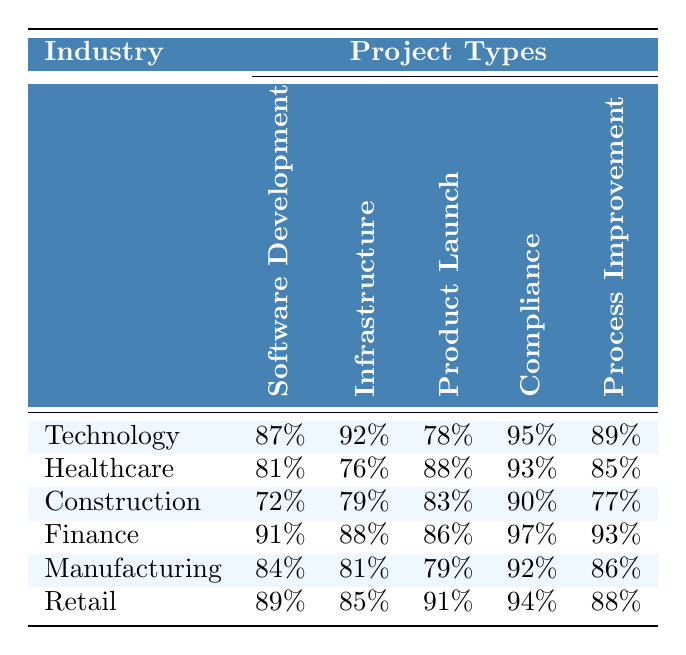What is the project completion rate for Software Development in the Finance industry? The table shows a completion rate of 91% for the Software Development project type in the Finance industry.
Answer: 91% Which industry has the highest completion rate for Compliance projects? According to the table, the Finance industry has the highest completion rate of 97% for Compliance projects.
Answer: Finance What is the average project completion rate for all project types in the Technology industry? The completion rates for Technology projects are 87%, 92%, 78%, 95%, and 89%. To find the average, sum these values: 87 + 92 + 78 + 95 + 89 = 441, then divide by 5, resulting in an average of 441/5 = 88.2.
Answer: 88.2% Is the completion rate for Retail projects higher in Product Launch or Process Improvement? The completion rate for Retail in Product Launch is 91%, while in Process Improvement, it is 88%. Since 91% is greater than 88%, Retail projects perform better in Product Launch.
Answer: Yes Which industry has the lowest project completion rate for Infrastructure projects? The table indicates that the Construction industry has the lowest completion rate for Infrastructure projects at 79%.
Answer: Construction What is the average project completion rate for Manufacturing across all project types? The rates for Manufacturing are 84%, 81%, 79%, 92%, and 86%. Summing these gives 84 + 81 + 79 + 92 + 86 = 422. Dividing by 5 leads to an average of 422/5 = 84.4.
Answer: 84.4% Which project type had the lowest completion rate in Healthcare? In the Healthcare industry, the lowest completion rate is 76% for Infrastructure projects, according to the table.
Answer: Infrastructure If we compare project completion rates for all industries in Software Development, which industry is second after Finance? The completion rates in Software Development for the relevant industries are: Technology 87%, Healthcare 81%, Construction 72%, Finance 91%, Manufacturing 84%, and Retail 89%. Excluding Finance, the highest completion rate observed is Retail at 89%. The second highest is Technology at 87%.
Answer: Technology How much lower is the completion rate for Construction in Compliance compared to Finance? The completion rate for Construction in Compliance is 90%, while Finance's is 97%. The difference can be calculated as 97 - 90 = 7.
Answer: 7% Which industry had a higher average project completion rate: Technology or Retail? The average completion rate for Technology is (87 + 92 + 78 + 95 + 89)/5 = 88.2%, and for Retail is (89 + 85 + 91 + 94 + 88)/5 = 89%. Since 89% for Retail is higher than 88.2% for Technology, Retail has the higher average.
Answer: Retail 